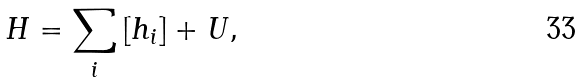Convert formula to latex. <formula><loc_0><loc_0><loc_500><loc_500>H = \sum _ { i } \left [ h _ { i } \right ] + U ,</formula> 